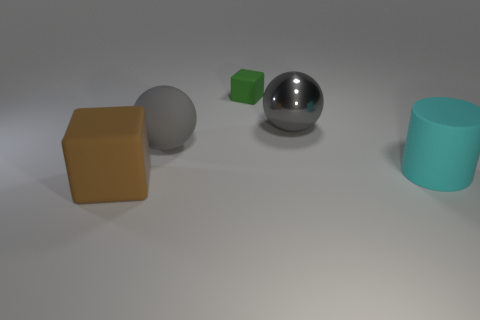Add 2 gray matte spheres. How many objects exist? 7 Subtract all spheres. How many objects are left? 3 Subtract 0 green cylinders. How many objects are left? 5 Subtract all brown metal things. Subtract all gray balls. How many objects are left? 3 Add 4 large cyan rubber cylinders. How many large cyan rubber cylinders are left? 5 Add 4 big blue matte cylinders. How many big blue matte cylinders exist? 4 